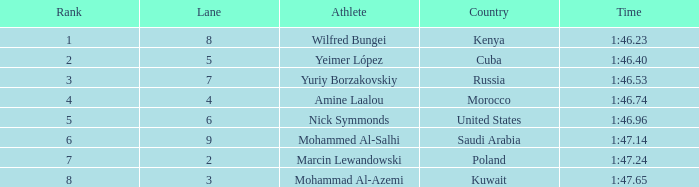What is the position of the athlete with a time of 1:4 None. Would you be able to parse every entry in this table? {'header': ['Rank', 'Lane', 'Athlete', 'Country', 'Time'], 'rows': [['1', '8', 'Wilfred Bungei', 'Kenya', '1:46.23'], ['2', '5', 'Yeimer López', 'Cuba', '1:46.40'], ['3', '7', 'Yuriy Borzakovskiy', 'Russia', '1:46.53'], ['4', '4', 'Amine Laalou', 'Morocco', '1:46.74'], ['5', '6', 'Nick Symmonds', 'United States', '1:46.96'], ['6', '9', 'Mohammed Al-Salhi', 'Saudi Arabia', '1:47.14'], ['7', '2', 'Marcin Lewandowski', 'Poland', '1:47.24'], ['8', '3', 'Mohammad Al-Azemi', 'Kuwait', '1:47.65']]} 